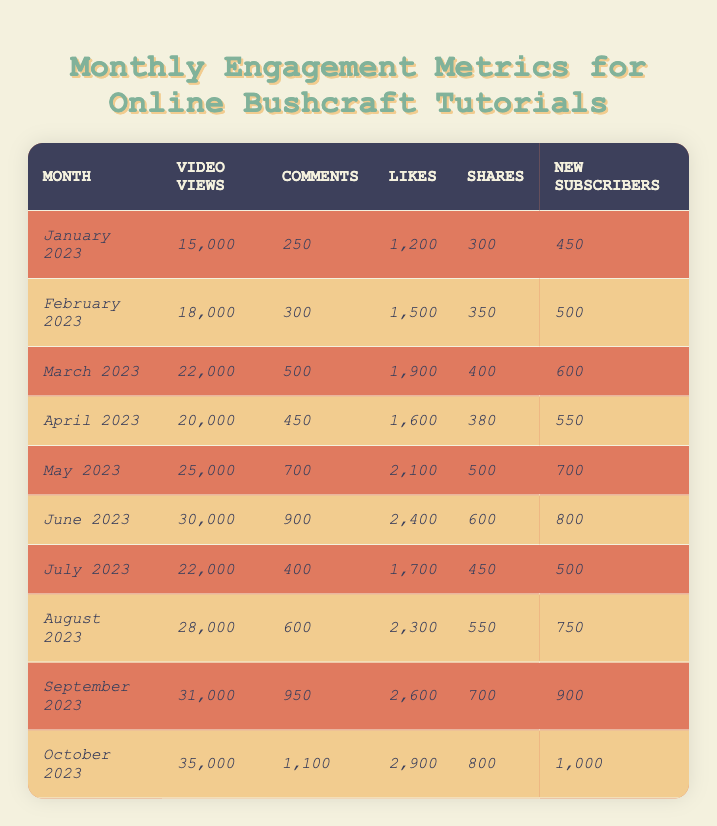What month had the highest number of video views? Looking at the table, October 2023 has the highest number of video views, which is 35,000.
Answer: October 2023 How many new subscribers were gained in June 2023? The table shows that in June 2023, the number of new subscribers gained was 800.
Answer: 800 What was the total number of likes from January to March 2023? To find the total likes from January to March 2023, we add the likes for each month: 1,200 (Jan) + 1,500 (Feb) + 1,900 (Mar) = 4,600.
Answer: 4,600 Did the number of shares in July 2023 exceed the number of shares in April 2023? In July 2023, the number of shares was 450, and in April 2023, it was 380. Since 450 is greater than 380, the answer is yes.
Answer: Yes What is the average number of video views for the months of May to October 2023? The video views for May to October are: 25,000 (May), 30,000 (June), 22,000 (July), 28,000 (August), 31,000 (September), and 35,000 (October). The total is 171,000. Dividing by 6 (the number of months) gives an average of 28,500.
Answer: 28,500 Which month saw the smallest increase in new subscribers compared to the previous month? Looking at the new subscribers: January (450), February (500), March (600), April (550), May (700), June (800), July (500), August (750), September (900), October (1,000). The smallest increase was from March to April, with a decrease of 50 new subscribers (600 to 550).
Answer: March to April How many more comments were made in September 2023 compared to January 2023? In September 2023, there were 950 comments, while in January 2023, there were 250 comments. Subtracting gives 950 - 250 = 700 more comments.
Answer: 700 What was the percentage increase in video views from January to June 2023? Video views increased from 15,000 in January to 30,000 in June. The increase is 30,000 - 15,000 = 15,000. The percentage increase = (15,000 / 15,000) * 100 = 100%.
Answer: 100% In which month did the total number of likes first exceed 2,000? The likes first exceeded 2,000 in May 2023, where there were 2,100 likes.
Answer: May 2023 What is the median number of shares across all months? The shares for all months are: 300 (Jan), 350 (Feb), 380 (Apr), 450 (Jul), 500 (May), 550 (Aug), 600 (Jun), 700 (Sep), and 800 (Oct). Arranging these numbers gives: 300, 350, 380, 450, 500, 550, 600, 700, 800. The median (the middle value) is 500.
Answer: 500 